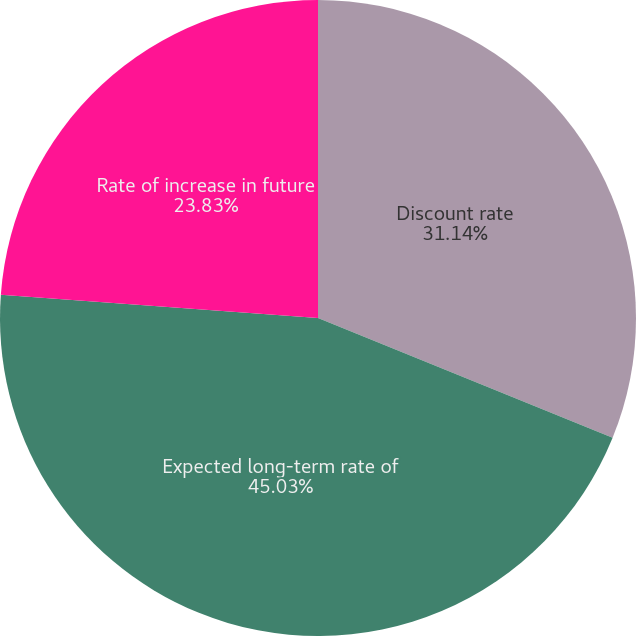<chart> <loc_0><loc_0><loc_500><loc_500><pie_chart><fcel>Discount rate<fcel>Expected long-term rate of<fcel>Rate of increase in future<nl><fcel>31.14%<fcel>45.02%<fcel>23.83%<nl></chart> 